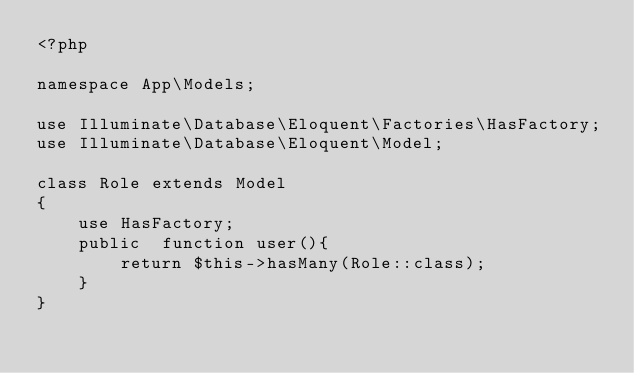Convert code to text. <code><loc_0><loc_0><loc_500><loc_500><_PHP_><?php

namespace App\Models;

use Illuminate\Database\Eloquent\Factories\HasFactory;
use Illuminate\Database\Eloquent\Model;

class Role extends Model
{
    use HasFactory;
    public  function user(){
        return $this->hasMany(Role::class);
    }
}
</code> 